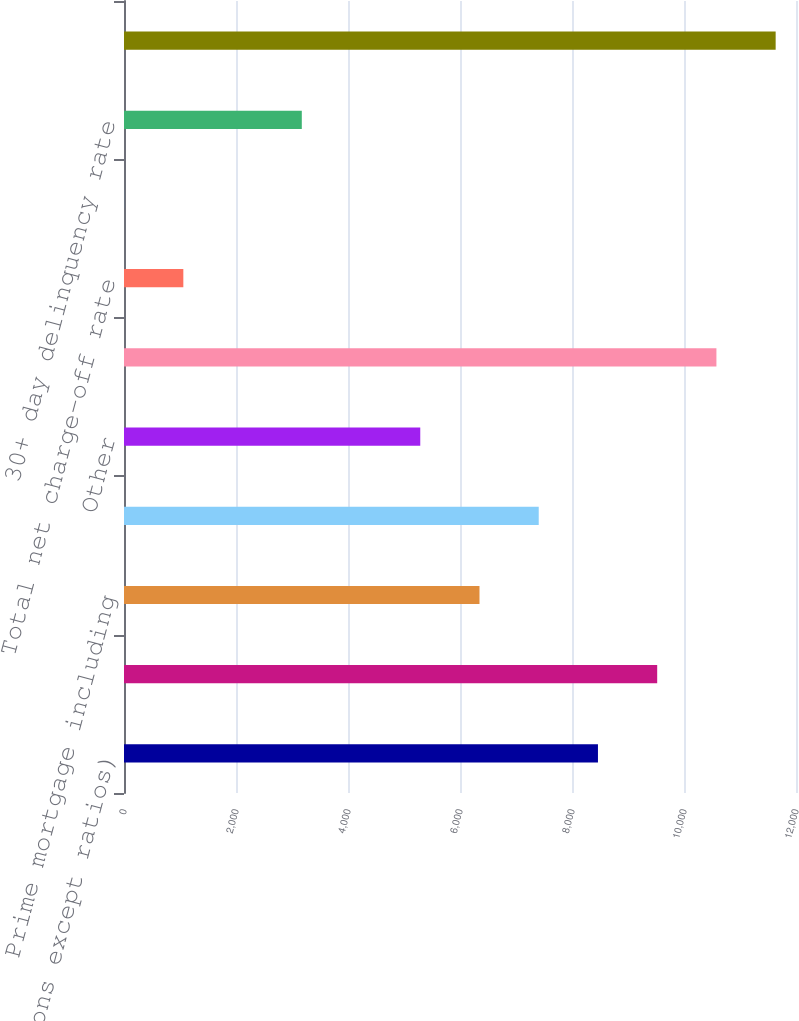Convert chart. <chart><loc_0><loc_0><loc_500><loc_500><bar_chart><fcel>(in millions except ratios)<fcel>Home equity<fcel>Prime mortgage including<fcel>Subprime mortgage<fcel>Other<fcel>Total net charge-offs<fcel>Total net charge-off rate<fcel>Total net charge-off rate -<fcel>30+ day delinquency rate<fcel>Allowance for loan losses<nl><fcel>8463.55<fcel>9521.27<fcel>6348.11<fcel>7405.83<fcel>5290.39<fcel>10579<fcel>1059.51<fcel>1.79<fcel>3174.95<fcel>11636.7<nl></chart> 